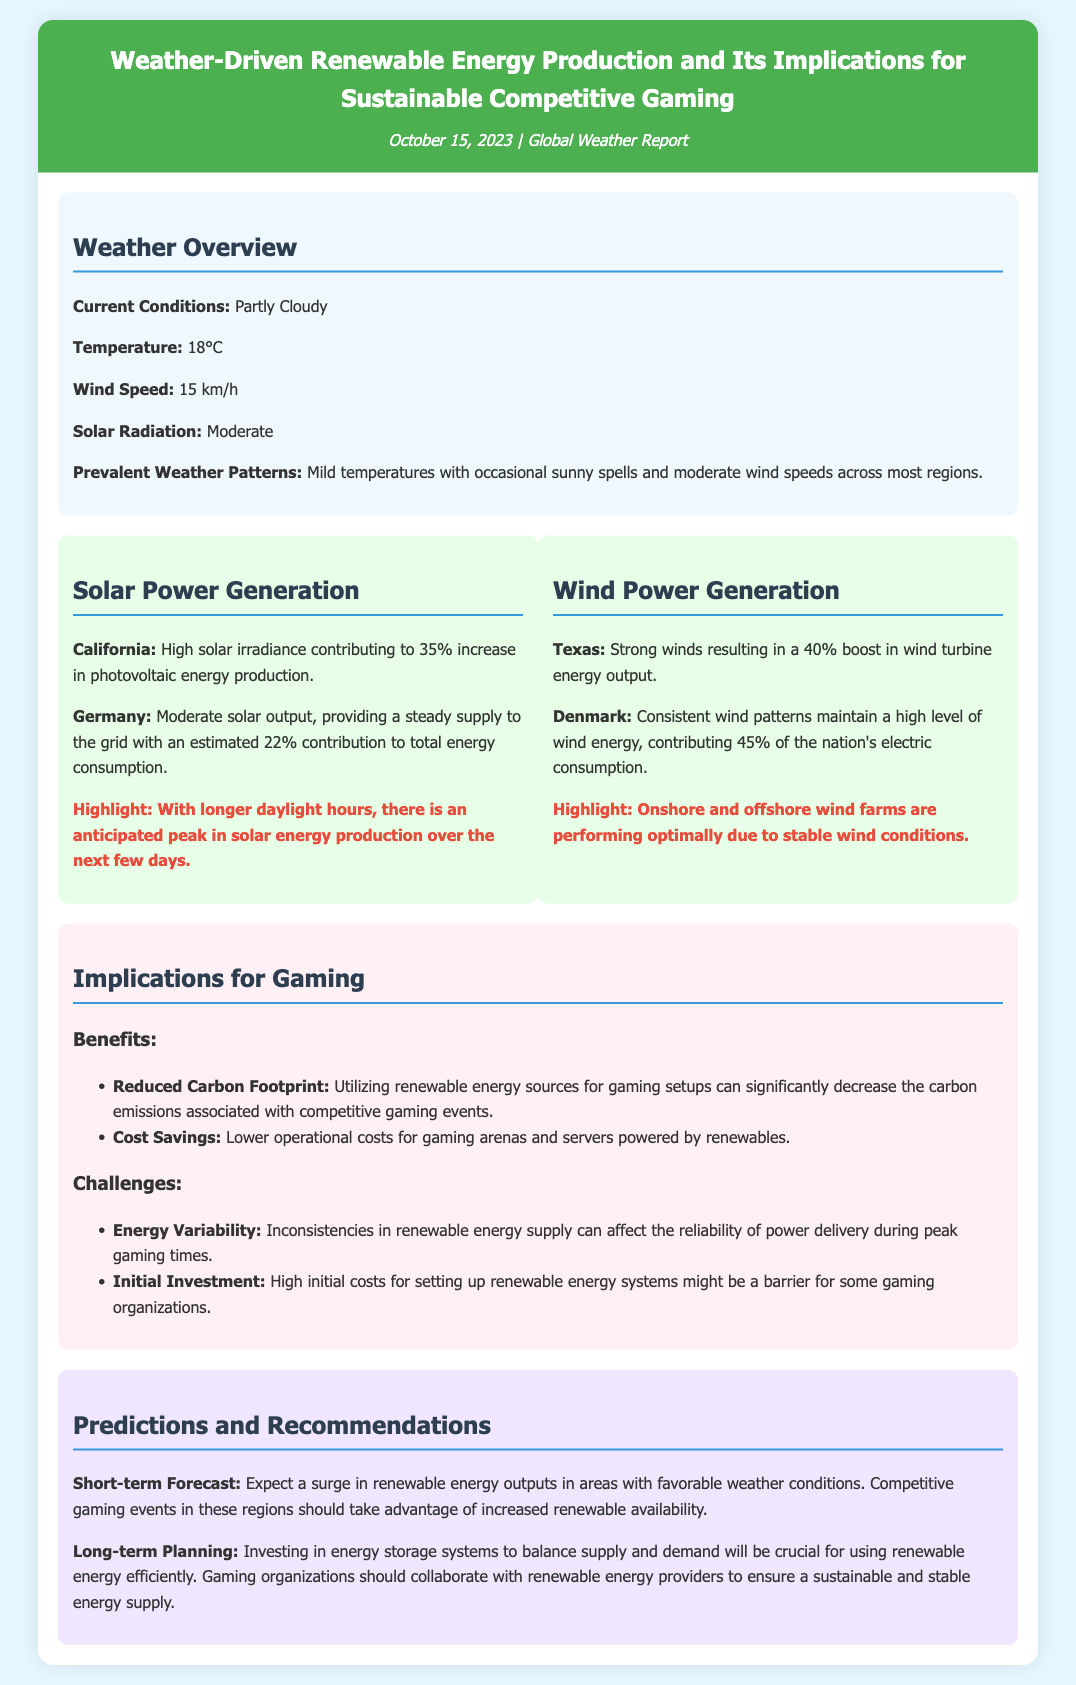What is the current temperature? The current temperature is provided in the weather overview section, which states it is 18°C.
Answer: 18°C What percentage increase in solar energy production is noted for California? The document specifies a 35% increase in photovoltaic energy production for California.
Answer: 35% What are the implications for gaming regarding renewable energy supply? The implications are detailed in the document under the challenges section, indicating energy variability can affect reliability during peak gaming times.
Answer: Energy Variability Which country contributes 45% of its electric consumption from wind energy? The document mentions Denmark as contributing 45% of the nation's electric consumption through wind energy.
Answer: Denmark What is highlighted about onshore and offshore wind farms? The wind power generation section highlights that these farms are performing optimally due to stable wind conditions.
Answer: Performing optimally What is recommended for balancing supply and demand in renewable energy usage? The document suggests investing in energy storage systems as crucial for balancing supply and demand.
Answer: Energy storage systems What weather condition contributes to a surge in renewable energy outputs? The document states that favorable weather conditions lead to a surge in renewable energy outputs.
Answer: Favorable weather conditions Which benefit is related to reduced carbon emissions? The benefits section specifies that utilizing renewable energy sources can significantly decrease the carbon emissions associated with competitive gaming events.
Answer: Reduced Carbon Footprint 